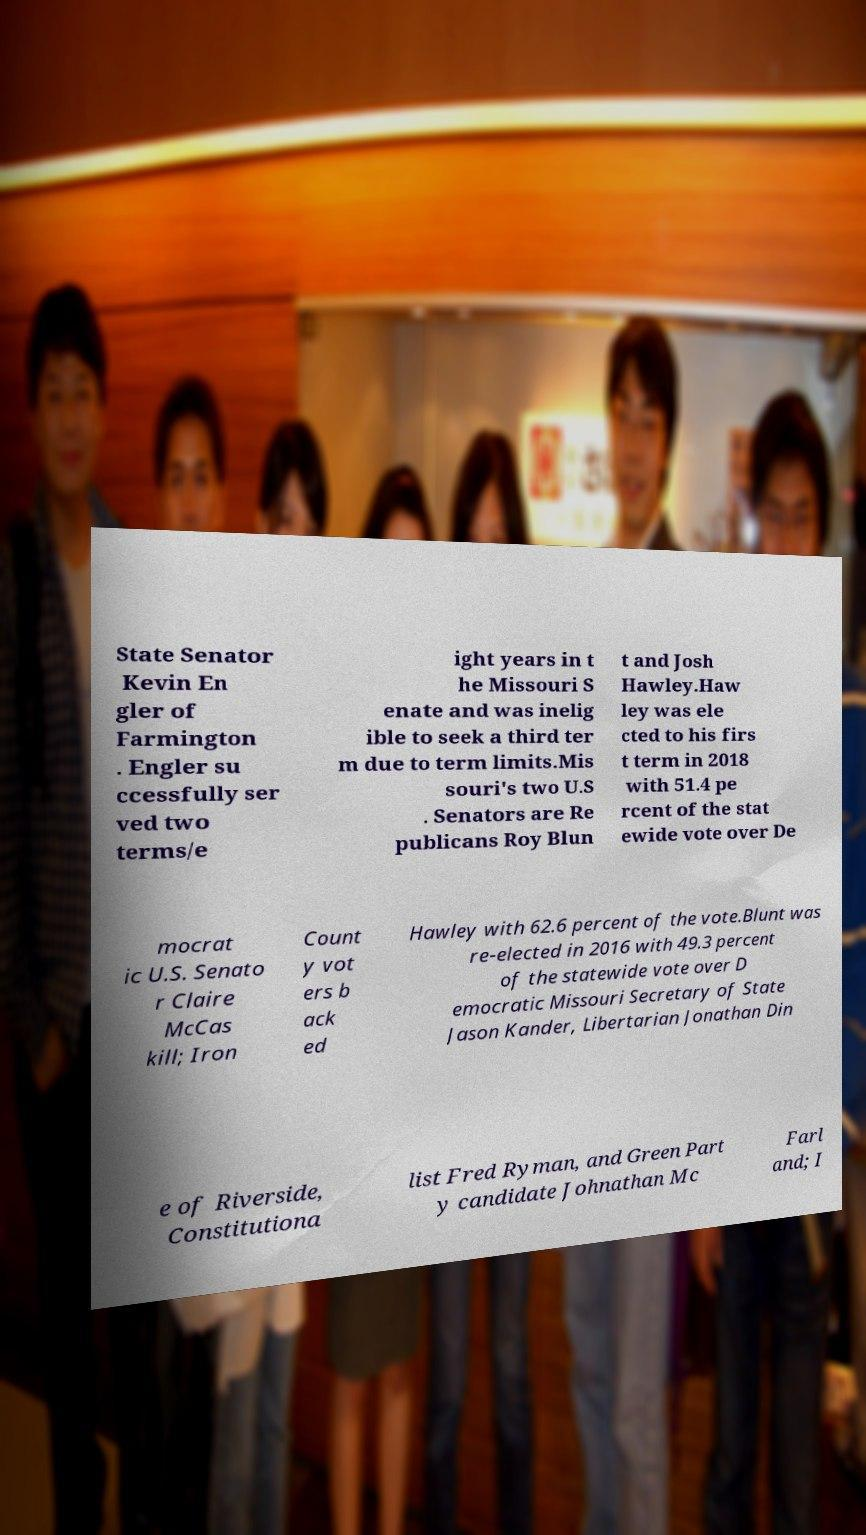What messages or text are displayed in this image? I need them in a readable, typed format. State Senator Kevin En gler of Farmington . Engler su ccessfully ser ved two terms/e ight years in t he Missouri S enate and was inelig ible to seek a third ter m due to term limits.Mis souri's two U.S . Senators are Re publicans Roy Blun t and Josh Hawley.Haw ley was ele cted to his firs t term in 2018 with 51.4 pe rcent of the stat ewide vote over De mocrat ic U.S. Senato r Claire McCas kill; Iron Count y vot ers b ack ed Hawley with 62.6 percent of the vote.Blunt was re-elected in 2016 with 49.3 percent of the statewide vote over D emocratic Missouri Secretary of State Jason Kander, Libertarian Jonathan Din e of Riverside, Constitutiona list Fred Ryman, and Green Part y candidate Johnathan Mc Farl and; I 